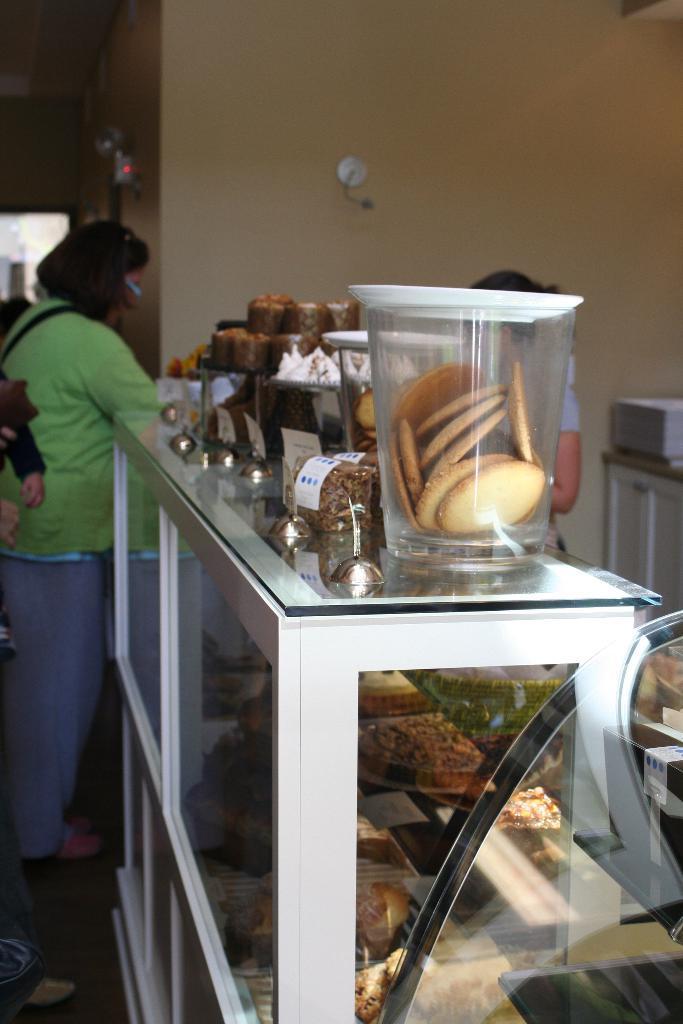Could you give a brief overview of what you see in this image? in a store there is a white table on which there are jars of food items. in the front there is a jar of cookies. in side the table there are food items in the rows. at the left a person is standing wearing green t shirt and a pant. at the right a person is standing. at the back there is a cream wall. 